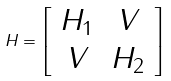<formula> <loc_0><loc_0><loc_500><loc_500>H = \left [ \begin{array} { c c } H _ { 1 } & V \\ V & H _ { 2 } \end{array} \right ]</formula> 